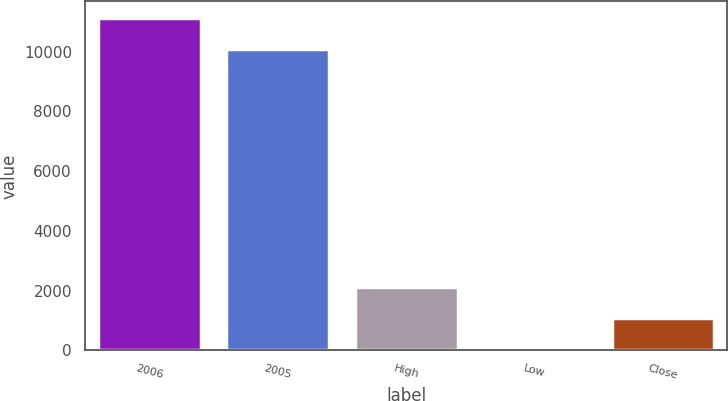Convert chart. <chart><loc_0><loc_0><loc_500><loc_500><bar_chart><fcel>2006<fcel>2005<fcel>High<fcel>Low<fcel>Close<nl><fcel>11128.2<fcel>10096<fcel>2125.53<fcel>61.15<fcel>1093.34<nl></chart> 